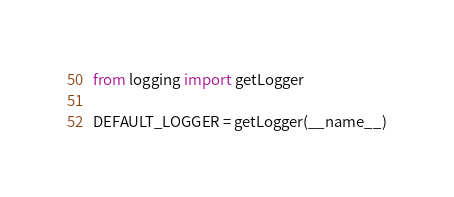Convert code to text. <code><loc_0><loc_0><loc_500><loc_500><_Python_>from logging import getLogger

DEFAULT_LOGGER = getLogger(__name__)
</code> 